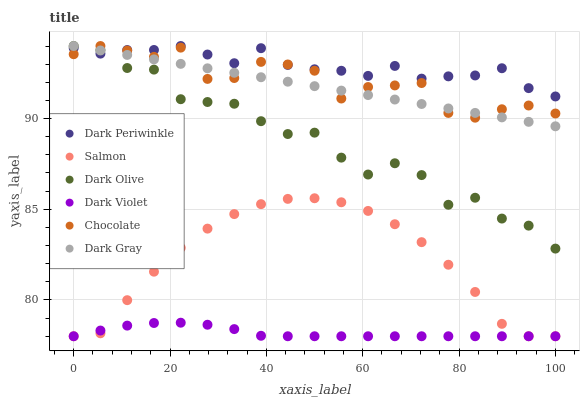Does Dark Violet have the minimum area under the curve?
Answer yes or no. Yes. Does Dark Periwinkle have the maximum area under the curve?
Answer yes or no. Yes. Does Salmon have the minimum area under the curve?
Answer yes or no. No. Does Salmon have the maximum area under the curve?
Answer yes or no. No. Is Dark Gray the smoothest?
Answer yes or no. Yes. Is Dark Olive the roughest?
Answer yes or no. Yes. Is Salmon the smoothest?
Answer yes or no. No. Is Salmon the roughest?
Answer yes or no. No. Does Salmon have the lowest value?
Answer yes or no. Yes. Does Chocolate have the lowest value?
Answer yes or no. No. Does Dark Periwinkle have the highest value?
Answer yes or no. Yes. Does Salmon have the highest value?
Answer yes or no. No. Is Salmon less than Dark Gray?
Answer yes or no. Yes. Is Dark Olive greater than Salmon?
Answer yes or no. Yes. Does Chocolate intersect Dark Periwinkle?
Answer yes or no. Yes. Is Chocolate less than Dark Periwinkle?
Answer yes or no. No. Is Chocolate greater than Dark Periwinkle?
Answer yes or no. No. Does Salmon intersect Dark Gray?
Answer yes or no. No. 